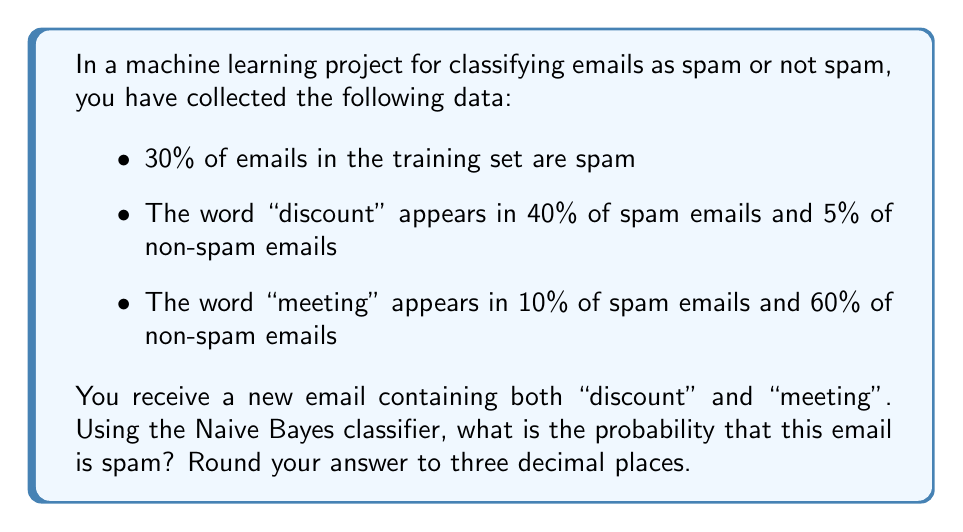Can you answer this question? Let's approach this step-by-step using the Naive Bayes formula:

1) Let S represent the event that an email is spam. We need to calculate P(S|D,M), where D represents "discount" and M represents "meeting".

2) The Naive Bayes formula is:

   $$P(S|D,M) = \frac{P(D|S) \cdot P(M|S) \cdot P(S)}{P(D|S) \cdot P(M|S) \cdot P(S) + P(D|\neg S) \cdot P(M|\neg S) \cdot P(\neg S)}$$

3) We're given:
   - P(S) = 0.30
   - P(D|S) = 0.40
   - P(M|S) = 0.10
   - P(D|¬S) = 0.05
   - P(M|¬S) = 0.60
   - P(¬S) = 1 - P(S) = 0.70

4) Let's substitute these values:

   $$P(S|D,M) = \frac{0.40 \cdot 0.10 \cdot 0.30}{0.40 \cdot 0.10 \cdot 0.30 + 0.05 \cdot 0.60 \cdot 0.70}$$

5) Calculate the numerator:
   $0.40 \cdot 0.10 \cdot 0.30 = 0.012$

6) Calculate the denominator:
   $0.40 \cdot 0.10 \cdot 0.30 + 0.05 \cdot 0.60 \cdot 0.70 = 0.012 + 0.021 = 0.033$

7) Divide:
   $$P(S|D,M) = \frac{0.012}{0.033} \approx 0.3636$$

8) Rounding to three decimal places: 0.364
Answer: 0.364 